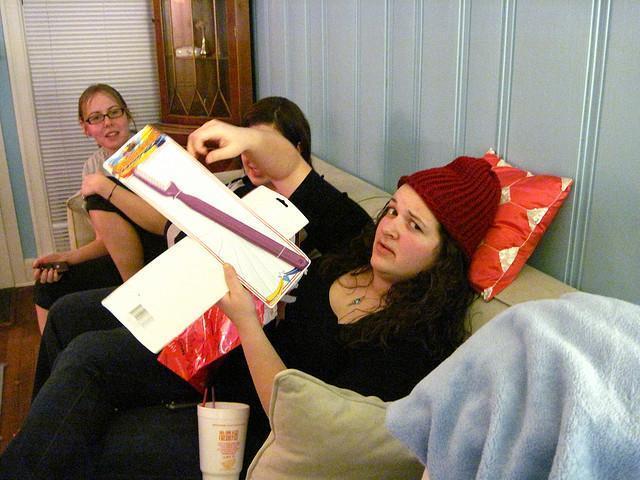How many people are there?
Give a very brief answer. 3. 